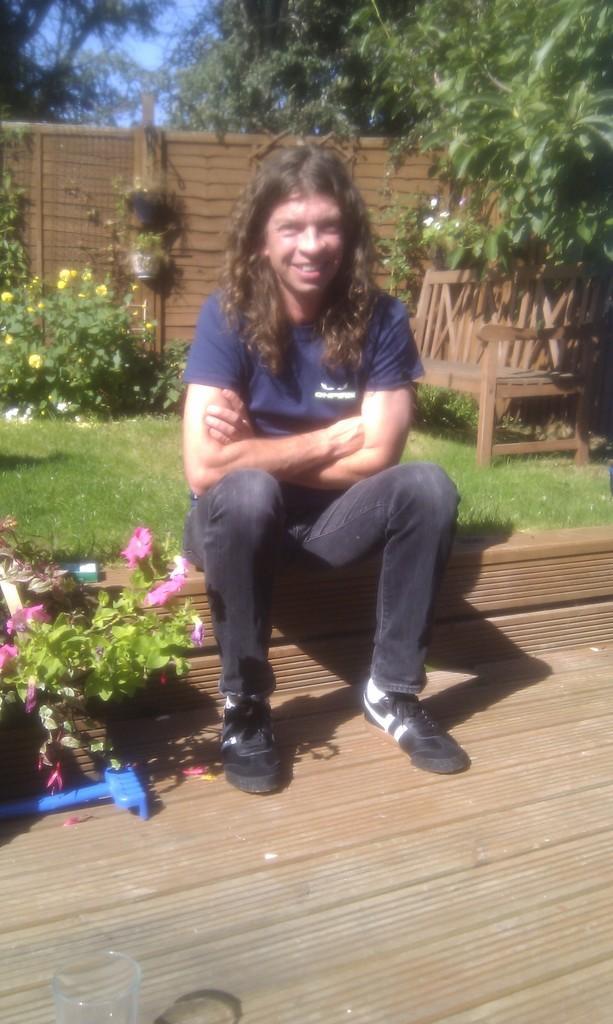Can you describe this image briefly? In the center of the image we can see a person sitting. On the right there is a bench. In the background we can see a fence and there are trees. At the bottom there are plants and we can see flowers. There is grass and we can see the sky. 